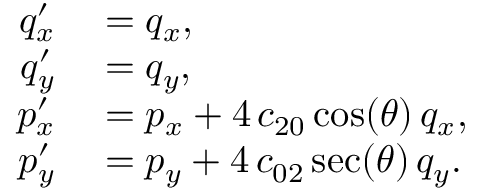<formula> <loc_0><loc_0><loc_500><loc_500>\begin{array} { r l } { q _ { x } ^ { \prime } } & = q _ { x } , } \\ { q _ { y } ^ { \prime } } & = q _ { y } , } \\ { p _ { x } ^ { \prime } } & = p _ { x } + 4 \, c _ { 2 0 } \cos ( \theta ) \, q _ { x } , } \\ { p _ { y } ^ { \prime } } & = p _ { y } + 4 \, c _ { 0 2 } \sec ( \theta ) \, q _ { y } . } \end{array}</formula> 